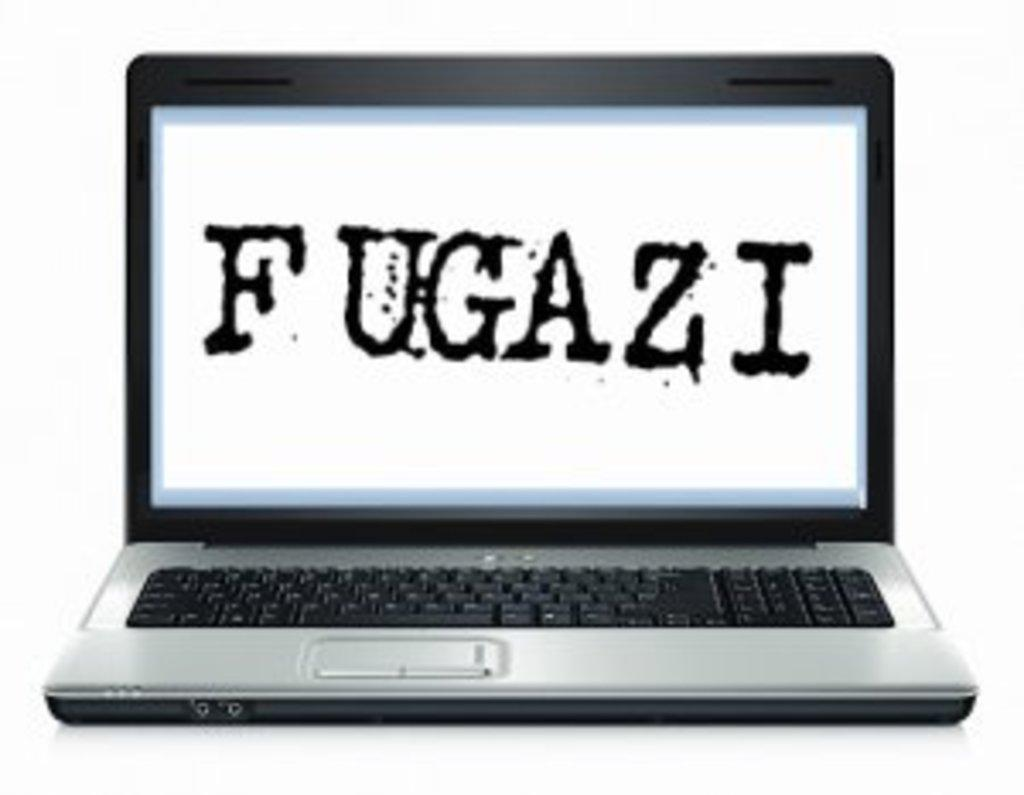Provide a one-sentence caption for the provided image. A computer with the word Fugazi on the screen in splatter style text sits open. 